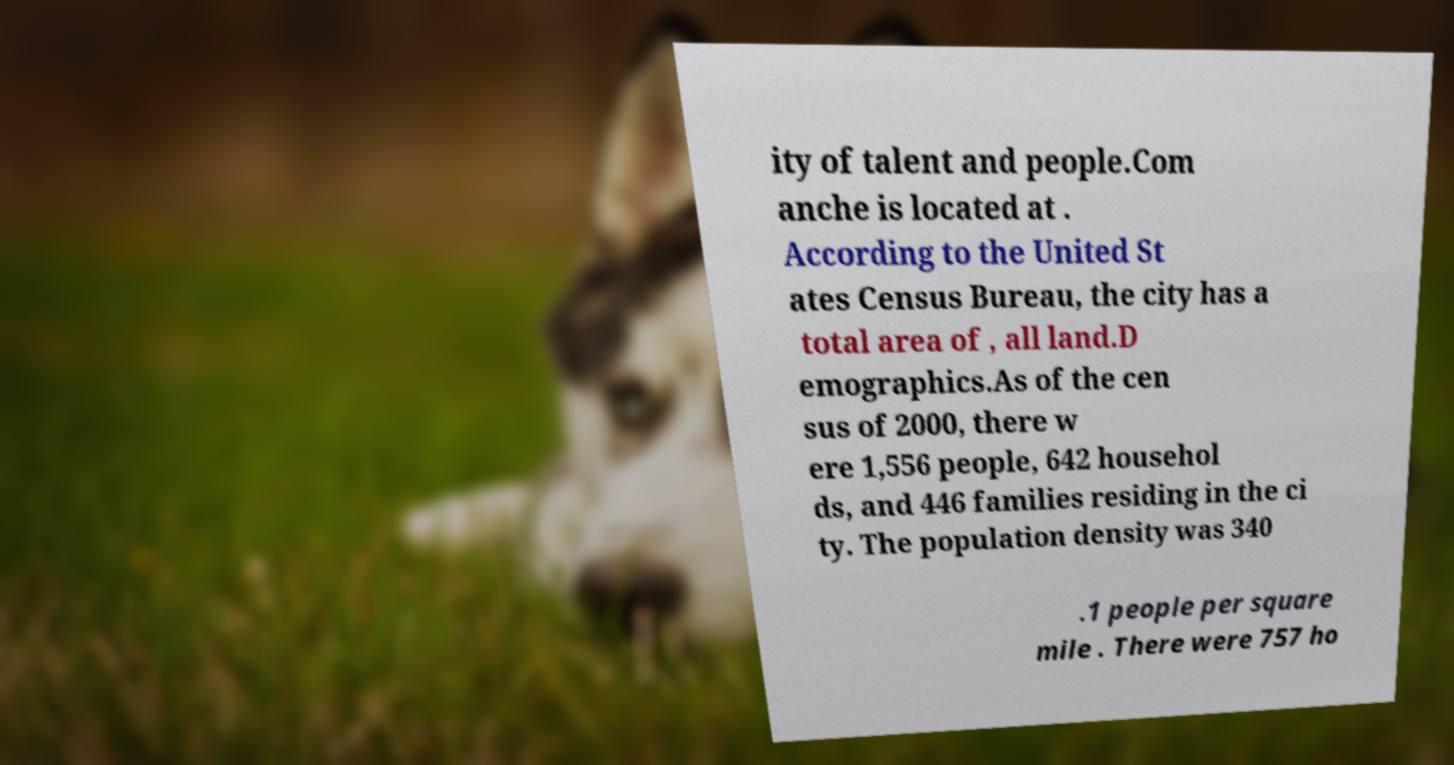I need the written content from this picture converted into text. Can you do that? ity of talent and people.Com anche is located at . According to the United St ates Census Bureau, the city has a total area of , all land.D emographics.As of the cen sus of 2000, there w ere 1,556 people, 642 househol ds, and 446 families residing in the ci ty. The population density was 340 .1 people per square mile . There were 757 ho 